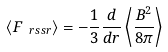Convert formula to latex. <formula><loc_0><loc_0><loc_500><loc_500>\langle F _ { \ r s s r } \rangle = - \frac { 1 } { 3 } \frac { d } { d r } \left \langle \frac { B ^ { 2 } } { 8 \pi } \right \rangle</formula> 